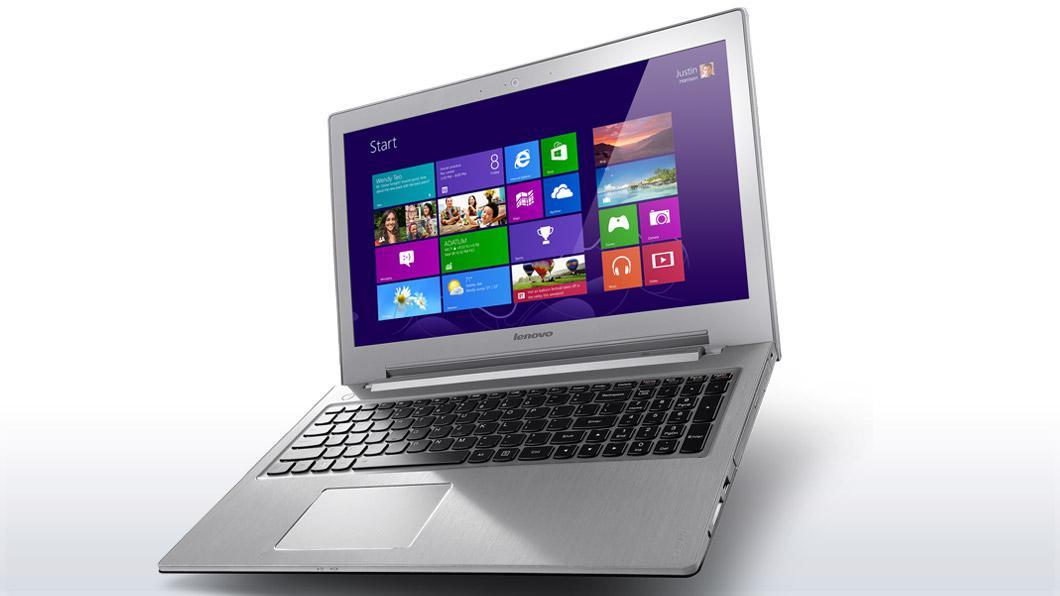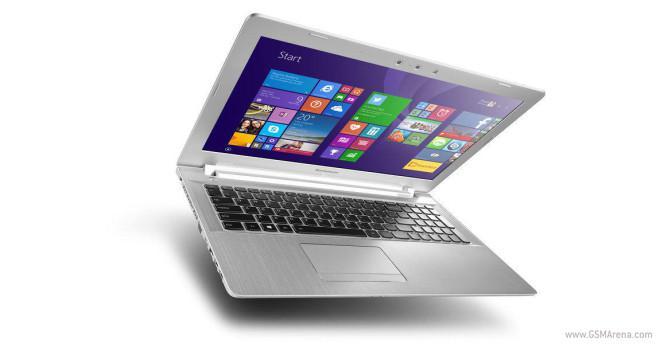The first image is the image on the left, the second image is the image on the right. For the images displayed, is the sentence "One of the displays shows a mountain." factually correct? Answer yes or no. No. 